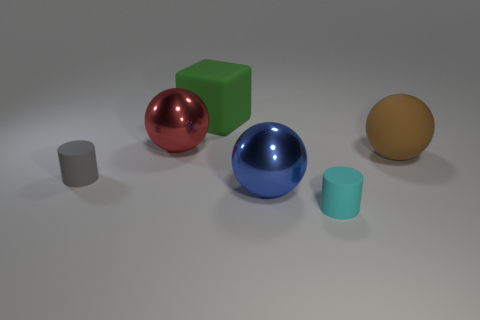Are there any tiny gray rubber objects that have the same shape as the large red thing?
Provide a short and direct response. No. Is the number of cylinders that are in front of the tiny gray thing less than the number of big red cubes?
Make the answer very short. No. What number of blue shiny spheres are there?
Make the answer very short. 1. What number of small gray cylinders have the same material as the large cube?
Offer a very short reply. 1. What number of things are either rubber cylinders that are behind the big blue shiny thing or red cubes?
Offer a very short reply. 1. Is the number of tiny gray things that are in front of the gray object less than the number of big green matte cubes left of the green thing?
Offer a terse response. No. There is a brown thing; are there any rubber cubes on the right side of it?
Keep it short and to the point. No. How many objects are either spheres to the right of the green rubber block or big shiny spheres that are on the left side of the rubber block?
Provide a short and direct response. 3. How many cylinders are the same color as the big rubber ball?
Your response must be concise. 0. What color is the rubber thing that is the same shape as the large red shiny thing?
Your response must be concise. Brown. 